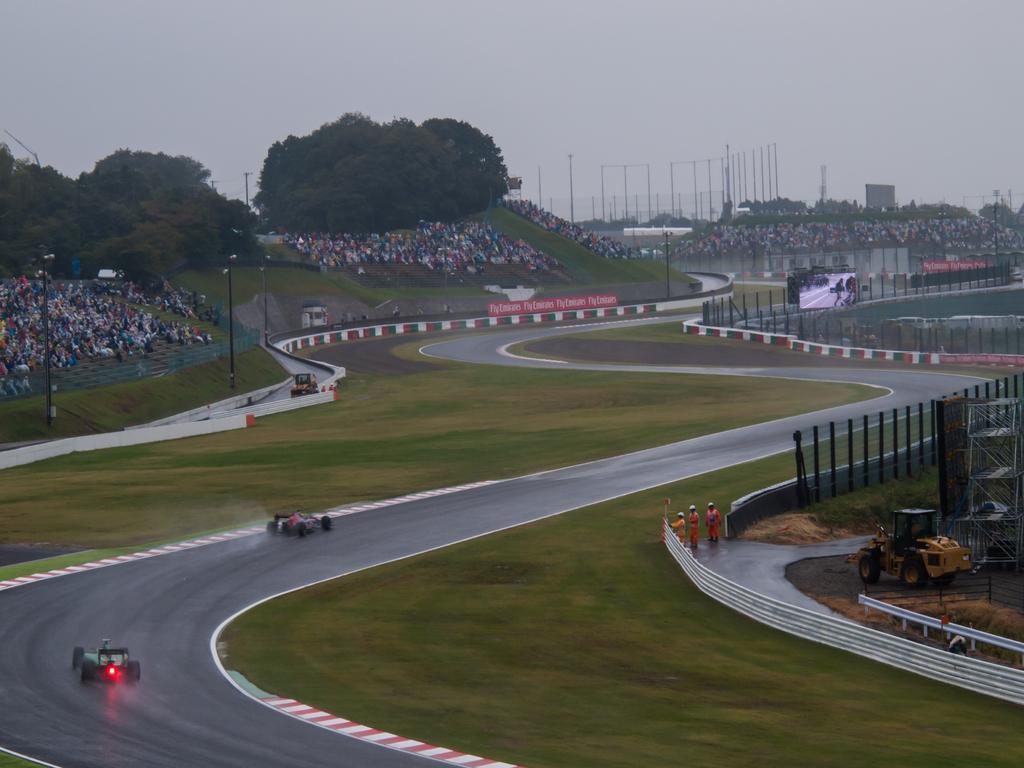Can you describe this image briefly? This is a picture taken during f1 or go kart race. In the foreground there are go karts, grass and road, people, road roller railing, fencing and other objects. In the center of the picture there are trees, audience, railing, grass, track and many other objects. Sky is cloudy. 